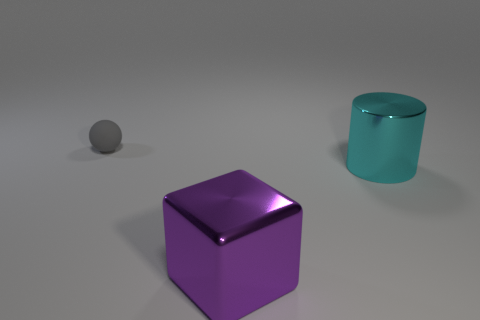Add 2 big cyan blocks. How many objects exist? 5 Subtract all spheres. How many objects are left? 2 Subtract all purple balls. Subtract all purple cylinders. How many balls are left? 1 Subtract all purple blocks. How many purple cylinders are left? 0 Subtract all large yellow metal cubes. Subtract all big cylinders. How many objects are left? 2 Add 1 small rubber balls. How many small rubber balls are left? 2 Add 3 cyan metallic objects. How many cyan metallic objects exist? 4 Subtract 0 brown spheres. How many objects are left? 3 